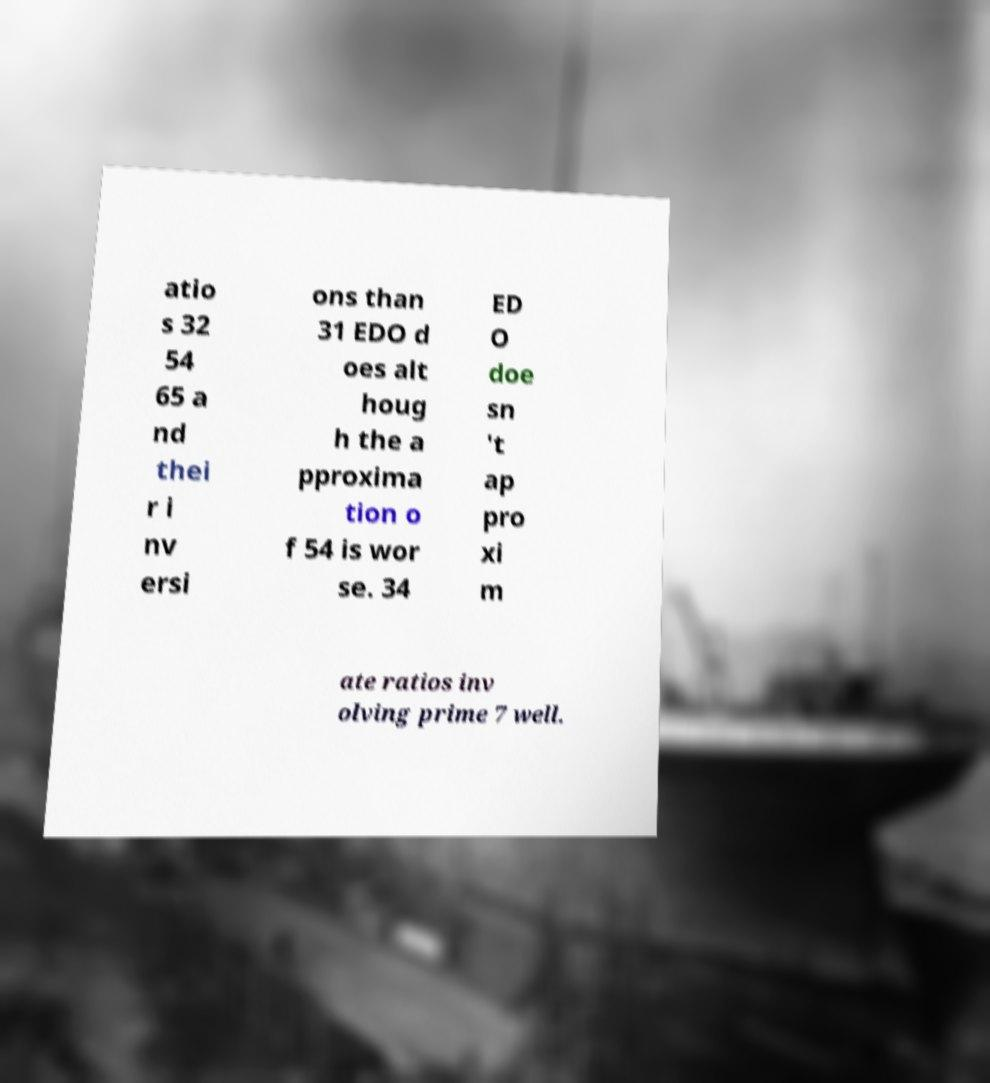Please identify and transcribe the text found in this image. atio s 32 54 65 a nd thei r i nv ersi ons than 31 EDO d oes alt houg h the a pproxima tion o f 54 is wor se. 34 ED O doe sn 't ap pro xi m ate ratios inv olving prime 7 well. 